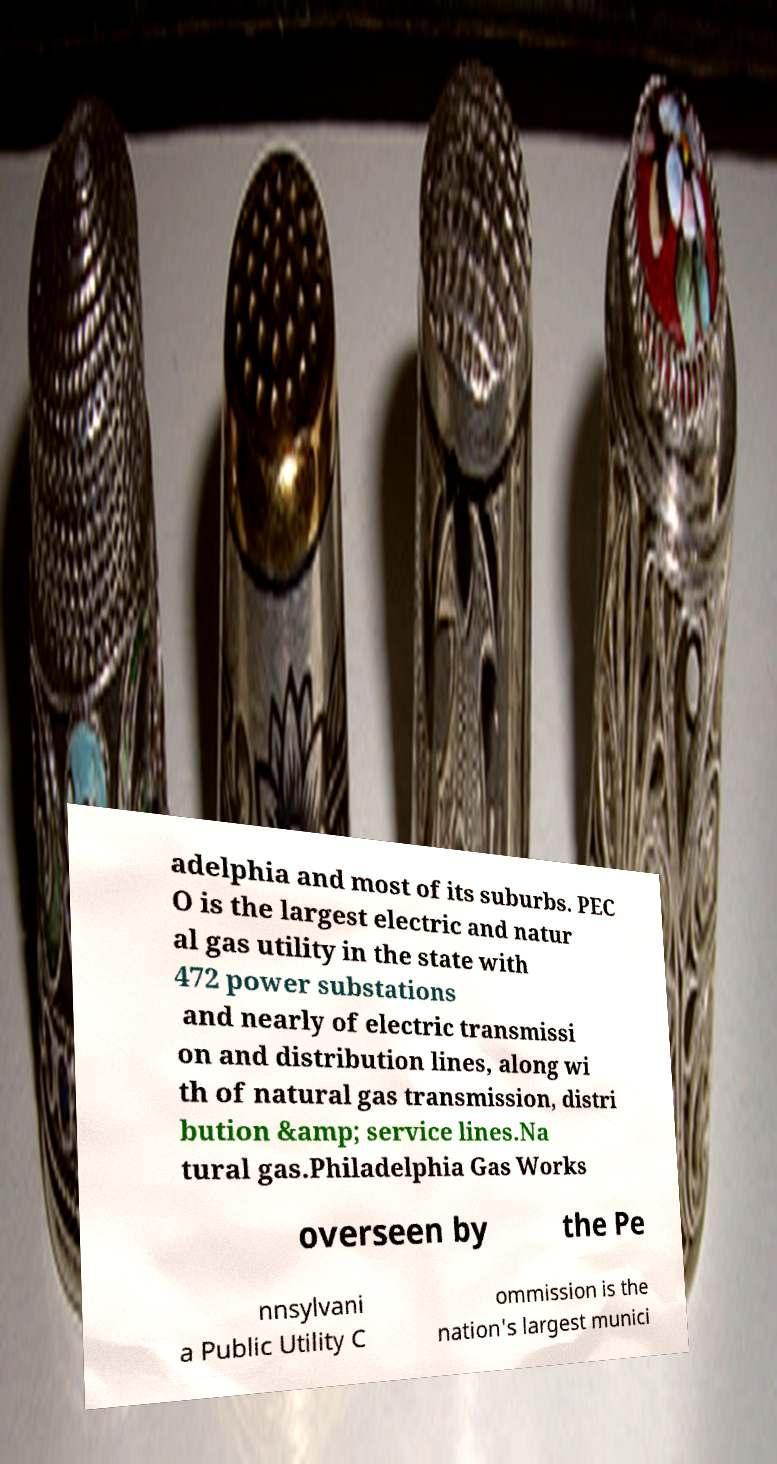Please read and relay the text visible in this image. What does it say? adelphia and most of its suburbs. PEC O is the largest electric and natur al gas utility in the state with 472 power substations and nearly of electric transmissi on and distribution lines, along wi th of natural gas transmission, distri bution &amp; service lines.Na tural gas.Philadelphia Gas Works overseen by the Pe nnsylvani a Public Utility C ommission is the nation's largest munici 